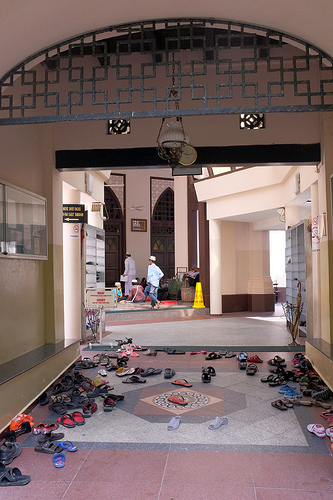<image>
Can you confirm if the man is to the left of the traffic cone? Yes. From this viewpoint, the man is positioned to the left side relative to the traffic cone. 